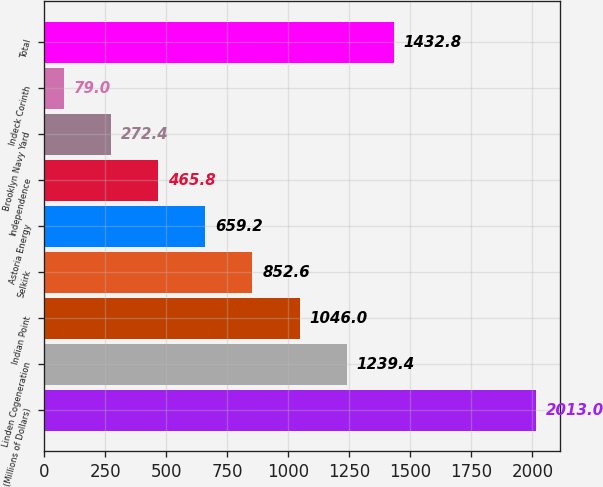Convert chart to OTSL. <chart><loc_0><loc_0><loc_500><loc_500><bar_chart><fcel>(Millions of Dollars)<fcel>Linden Cogeneration<fcel>Indian Point<fcel>Selkirk<fcel>Astoria Energy<fcel>Independence<fcel>Brooklyn Navy Yard<fcel>Indeck Corinth<fcel>Total<nl><fcel>2013<fcel>1239.4<fcel>1046<fcel>852.6<fcel>659.2<fcel>465.8<fcel>272.4<fcel>79<fcel>1432.8<nl></chart> 